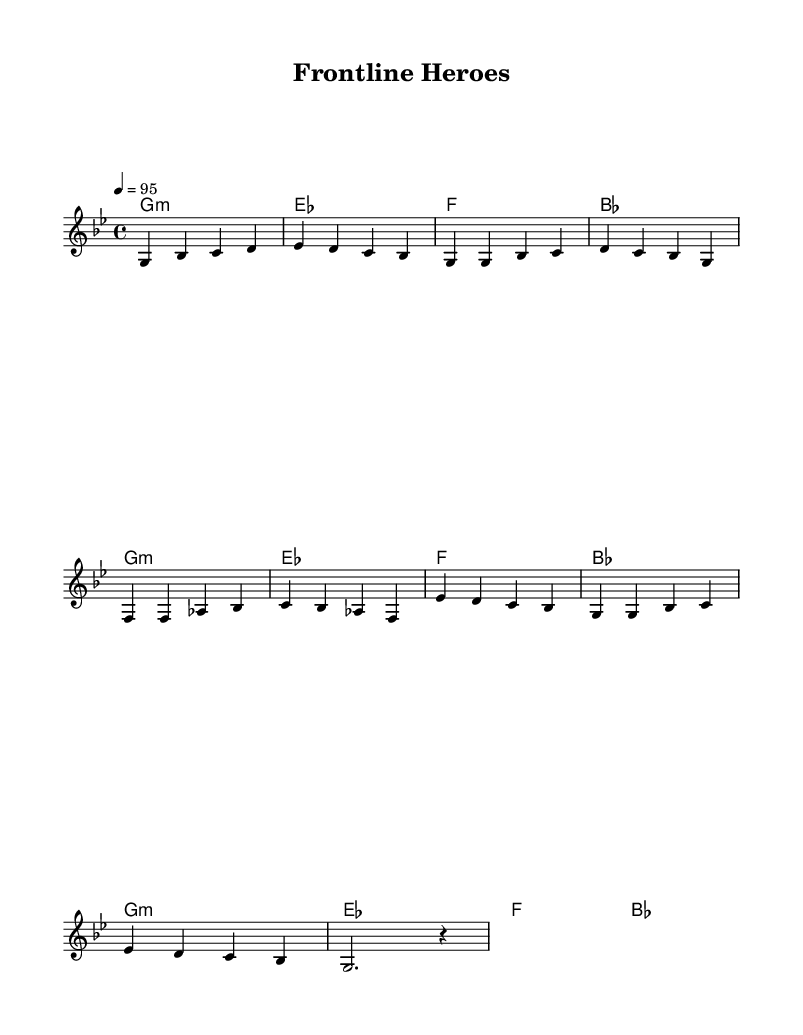What is the key signature of this music? The key signature is indicated by the sharp or flat symbols in the music. In this piece, there are no sharps or flats indicated, meaning it is in G minor which has two flats.
Answer: G minor What is the time signature of this music? The time signature is shown at the beginning right after the key signature. In this case, it is 4/4, meaning there are four beats in each measure.
Answer: 4/4 What is the tempo marking for this piece? The tempo marking is provided near the beginning of the score and indicates the speed of the music. Here, it states "4 = 95," which means there are 95 beats per minute.
Answer: 95 How many measures does the chorus contain? By counting the groupings of notes and bars in the score, we see that the chorus section consists of four measures.
Answer: 4 What is the first chord of the piece? The first chord is presented in the harmonies section, where the first chord shown is labeled as G minor, which corresponds to the first chord in the sequence.
Answer: G minor Which section of the music does the melody start with? By examining the structure of the music, we can identify that the melody begins with an intro section of notes before moving into the verse.
Answer: Intro Is this music written in a minor or major key? By looking at the key signature and the overall feel of the melody and harmony, it can be determined that the music is in a minor key, specifically G minor.
Answer: Minor 